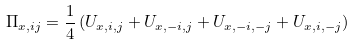<formula> <loc_0><loc_0><loc_500><loc_500>\Pi _ { x , i j } = \frac { 1 } { 4 } \left ( U _ { x , i , j } + U _ { x , - i , j } + U _ { x , - i , - j } + U _ { x , i , - j } \right )</formula> 